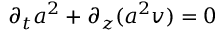Convert formula to latex. <formula><loc_0><loc_0><loc_500><loc_500>\partial _ { t } a ^ { 2 } + \partial _ { z } ( a ^ { 2 } v ) = 0</formula> 